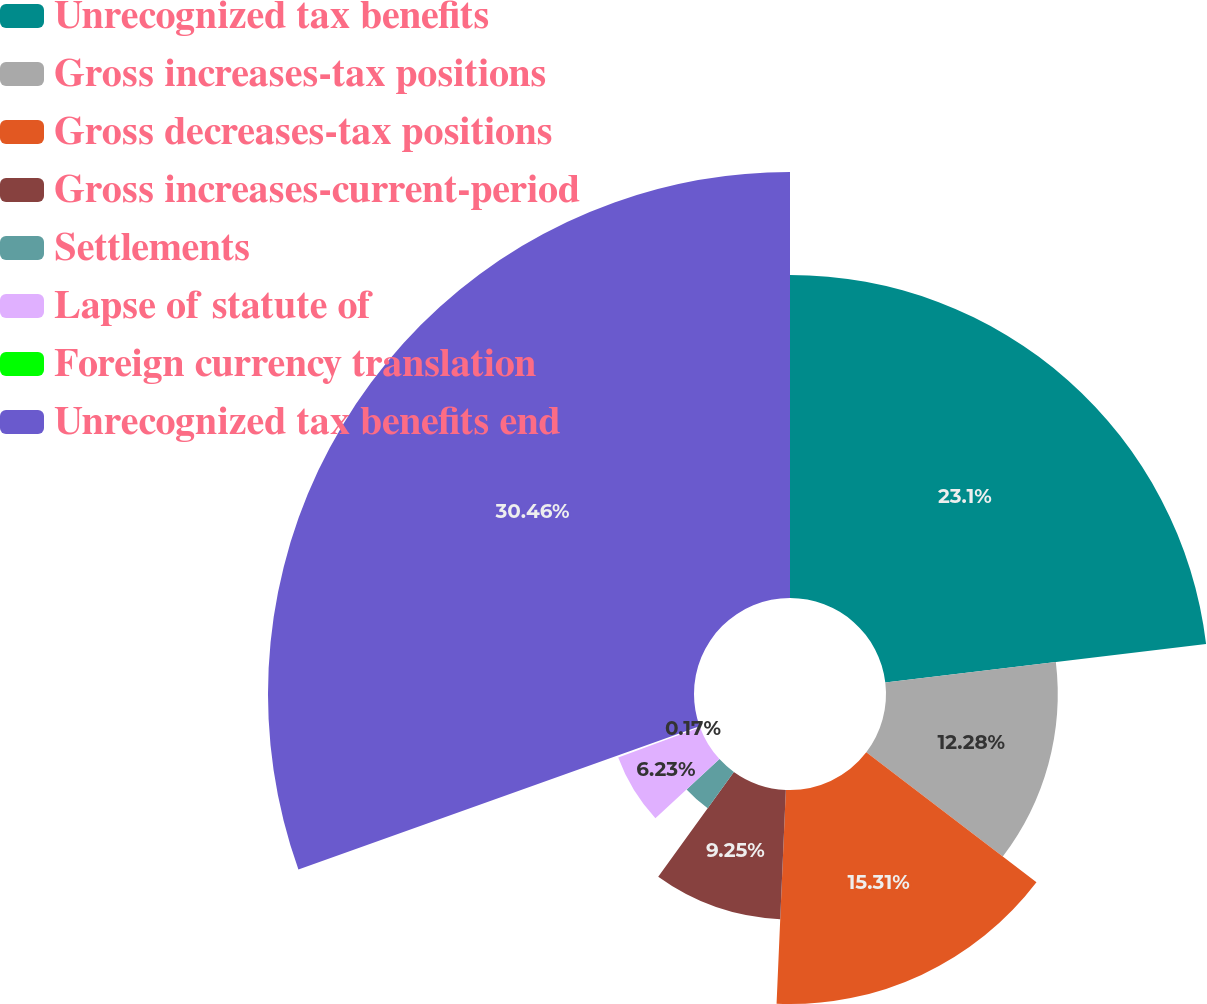<chart> <loc_0><loc_0><loc_500><loc_500><pie_chart><fcel>Unrecognized tax benefits<fcel>Gross increases-tax positions<fcel>Gross decreases-tax positions<fcel>Gross increases-current-period<fcel>Settlements<fcel>Lapse of statute of<fcel>Foreign currency translation<fcel>Unrecognized tax benefits end<nl><fcel>23.1%<fcel>12.28%<fcel>15.31%<fcel>9.25%<fcel>3.2%<fcel>6.23%<fcel>0.17%<fcel>30.46%<nl></chart> 